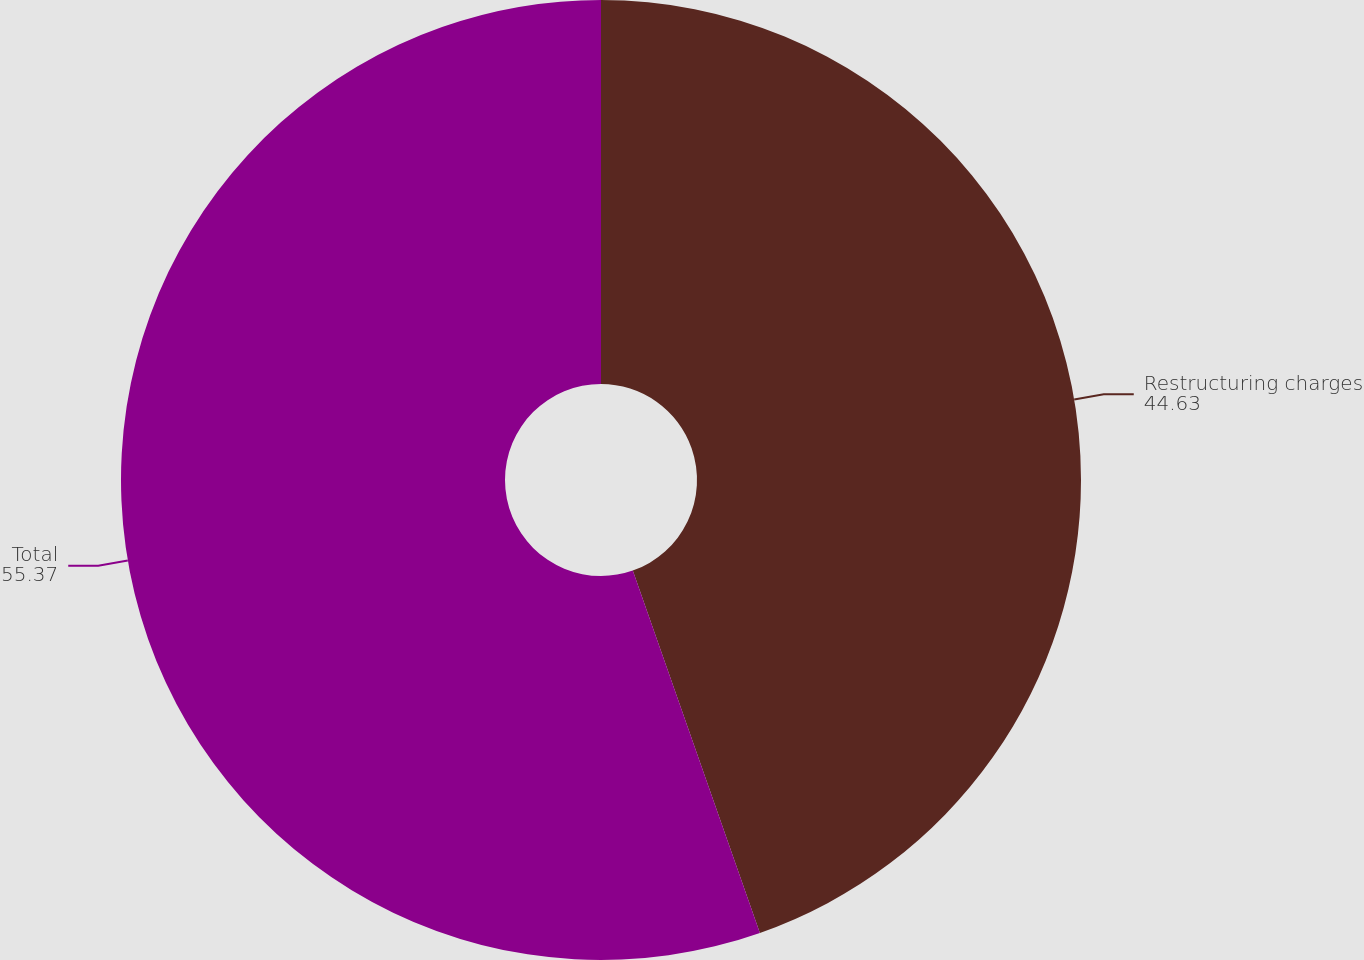Convert chart. <chart><loc_0><loc_0><loc_500><loc_500><pie_chart><fcel>Restructuring charges<fcel>Total<nl><fcel>44.63%<fcel>55.37%<nl></chart> 